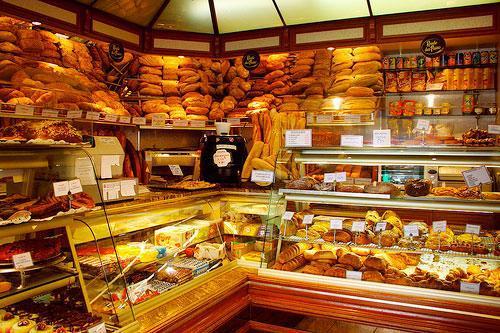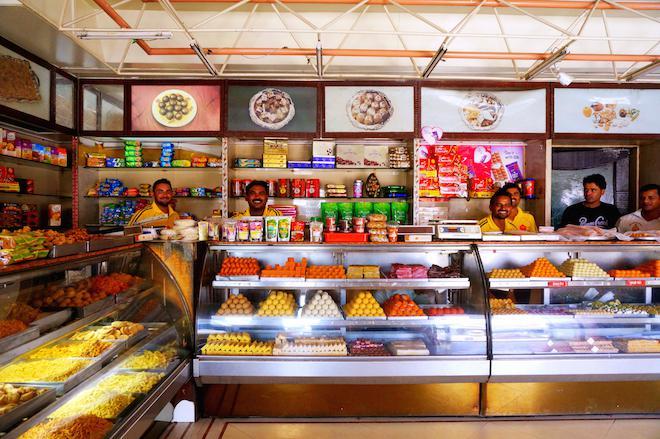The first image is the image on the left, the second image is the image on the right. Assess this claim about the two images: "The bakery's name is visible in at least one image.". Correct or not? Answer yes or no. No. The first image is the image on the left, the second image is the image on the right. For the images displayed, is the sentence "In at least one image there is no less than 4 men standing behind the baked goods counter." factually correct? Answer yes or no. Yes. 